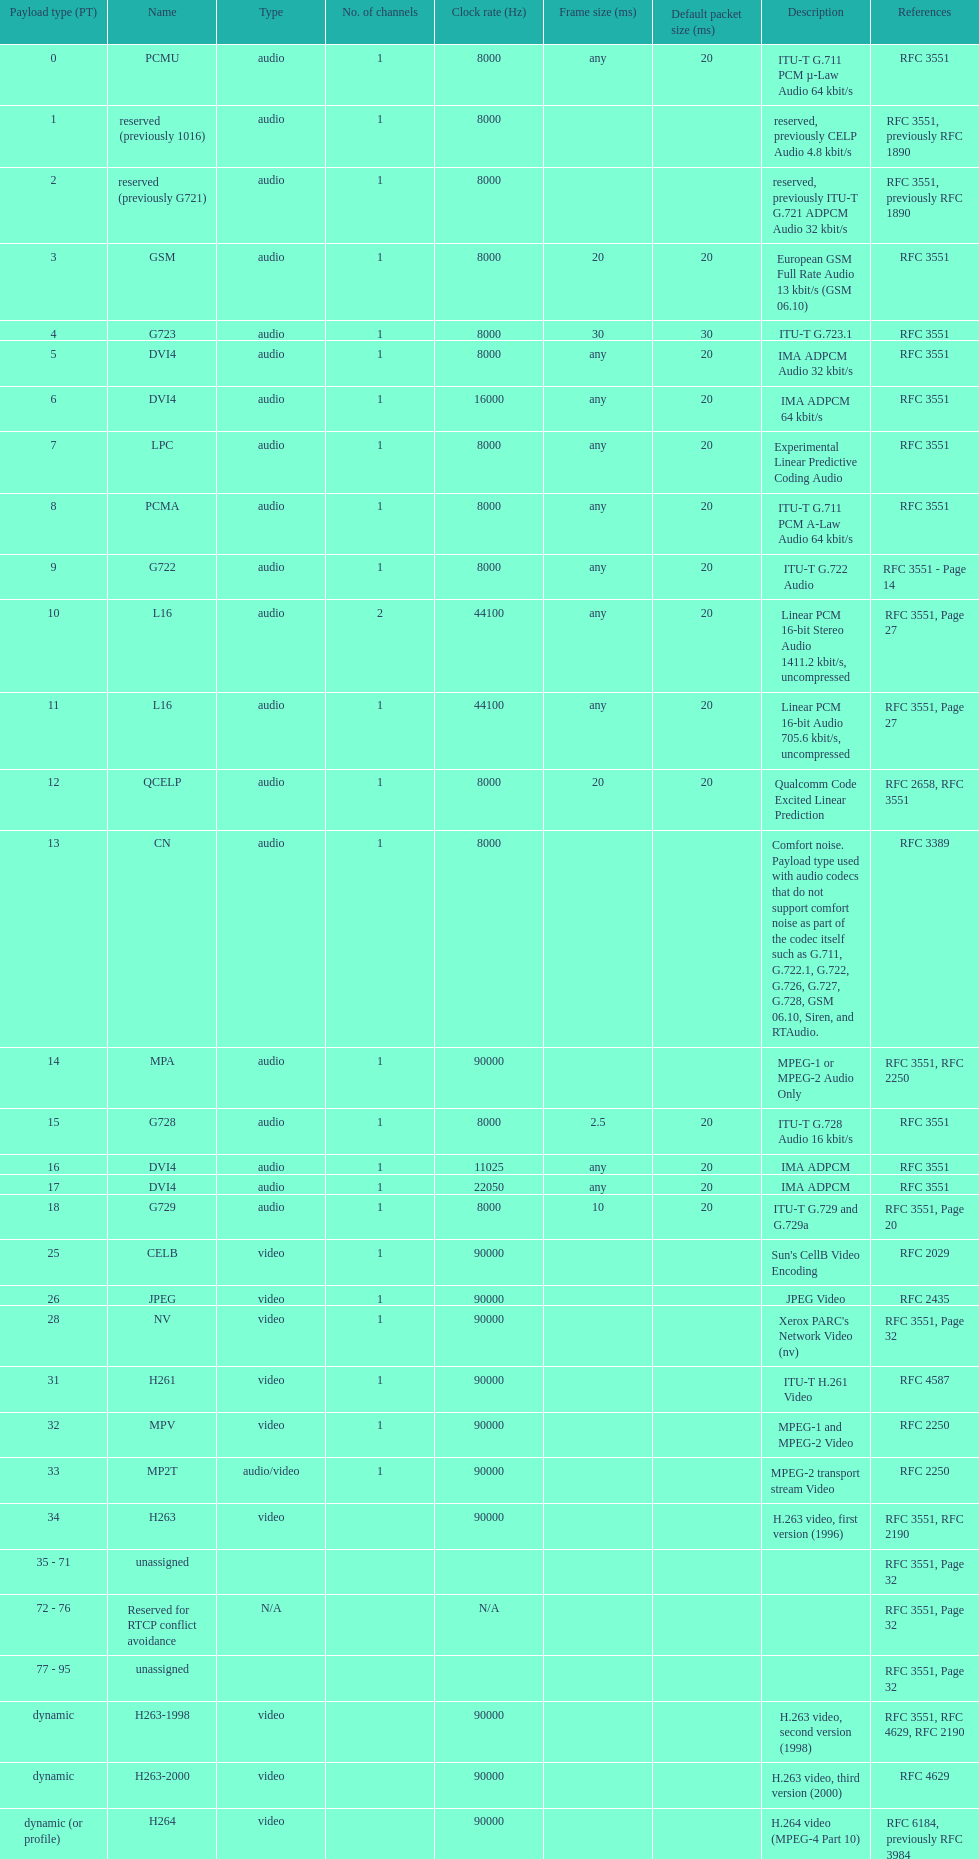Excluding audio, which other payload types are available? Video. 